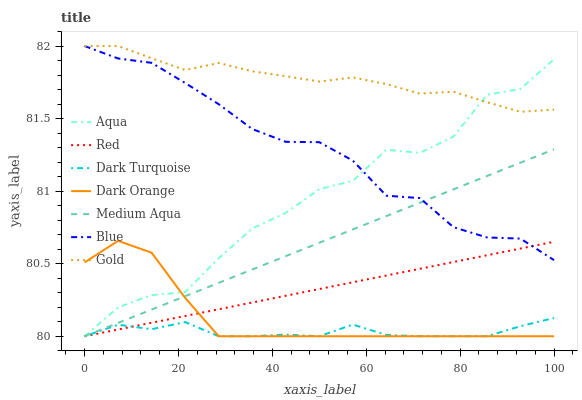Does Dark Turquoise have the minimum area under the curve?
Answer yes or no. Yes. Does Gold have the maximum area under the curve?
Answer yes or no. Yes. Does Dark Orange have the minimum area under the curve?
Answer yes or no. No. Does Dark Orange have the maximum area under the curve?
Answer yes or no. No. Is Medium Aqua the smoothest?
Answer yes or no. Yes. Is Aqua the roughest?
Answer yes or no. Yes. Is Dark Orange the smoothest?
Answer yes or no. No. Is Dark Orange the roughest?
Answer yes or no. No. Does Dark Orange have the lowest value?
Answer yes or no. Yes. Does Gold have the lowest value?
Answer yes or no. No. Does Gold have the highest value?
Answer yes or no. Yes. Does Dark Orange have the highest value?
Answer yes or no. No. Is Dark Orange less than Gold?
Answer yes or no. Yes. Is Gold greater than Medium Aqua?
Answer yes or no. Yes. Does Aqua intersect Dark Turquoise?
Answer yes or no. Yes. Is Aqua less than Dark Turquoise?
Answer yes or no. No. Is Aqua greater than Dark Turquoise?
Answer yes or no. No. Does Dark Orange intersect Gold?
Answer yes or no. No. 